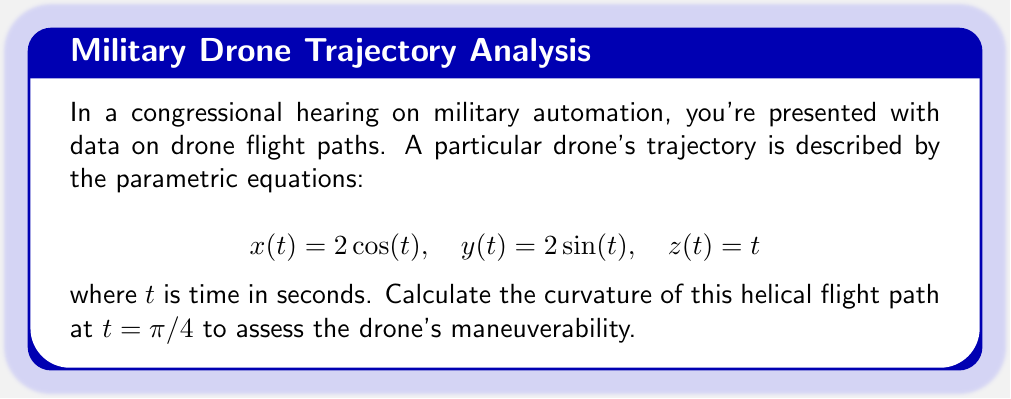Help me with this question. To calculate the curvature of a three-dimensional curve, we'll use the formula:

$$\kappa = \frac{\|\mathbf{r}'(t) \times \mathbf{r}''(t)\|}{\|\mathbf{r}'(t)\|^3}$$

where $\mathbf{r}(t) = (x(t), y(t), z(t))$ is the position vector.

Step 1: Calculate $\mathbf{r}'(t)$
$$\mathbf{r}'(t) = (-2\sin(t), 2\cos(t), 1)$$

Step 2: Calculate $\mathbf{r}''(t)$
$$\mathbf{r}''(t) = (-2\cos(t), -2\sin(t), 0)$$

Step 3: Calculate $\mathbf{r}'(t) \times \mathbf{r}''(t)$
$$\mathbf{r}'(t) \times \mathbf{r}''(t) = (2\sin(t), -2\cos(t), 4)$$

Step 4: Calculate $\|\mathbf{r}'(t) \times \mathbf{r}''(t)\|$
$$\|\mathbf{r}'(t) \times \mathbf{r}''(t)\| = \sqrt{4\sin^2(t) + 4\cos^2(t) + 16} = \sqrt{20}$$

Step 5: Calculate $\|\mathbf{r}'(t)\|$
$$\|\mathbf{r}'(t)\| = \sqrt{4\sin^2(t) + 4\cos^2(t) + 1} = \sqrt{5}$$

Step 6: Apply the curvature formula at $t = \pi/4$
$$\kappa = \frac{\sqrt{20}}{(\sqrt{5})^3} = \frac{2\sqrt{5}}{25}$$
Answer: $\frac{2\sqrt{5}}{25}$ 